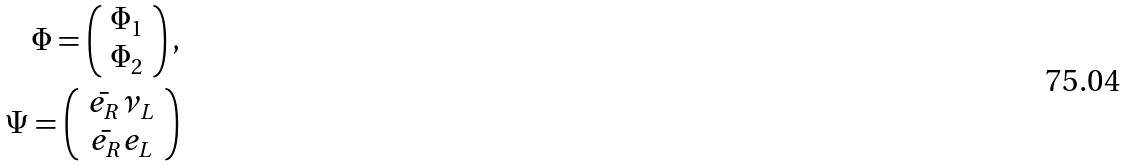Convert formula to latex. <formula><loc_0><loc_0><loc_500><loc_500>\Phi = \left ( \begin{array} { c } \Phi _ { 1 } \\ \Phi _ { 2 } \end{array} \right ) , \\ \Psi = \left ( \begin{array} { c } \bar { e _ { R } } \nu _ { L } \\ \bar { e _ { R } } e _ { L } \end{array} \right )</formula> 